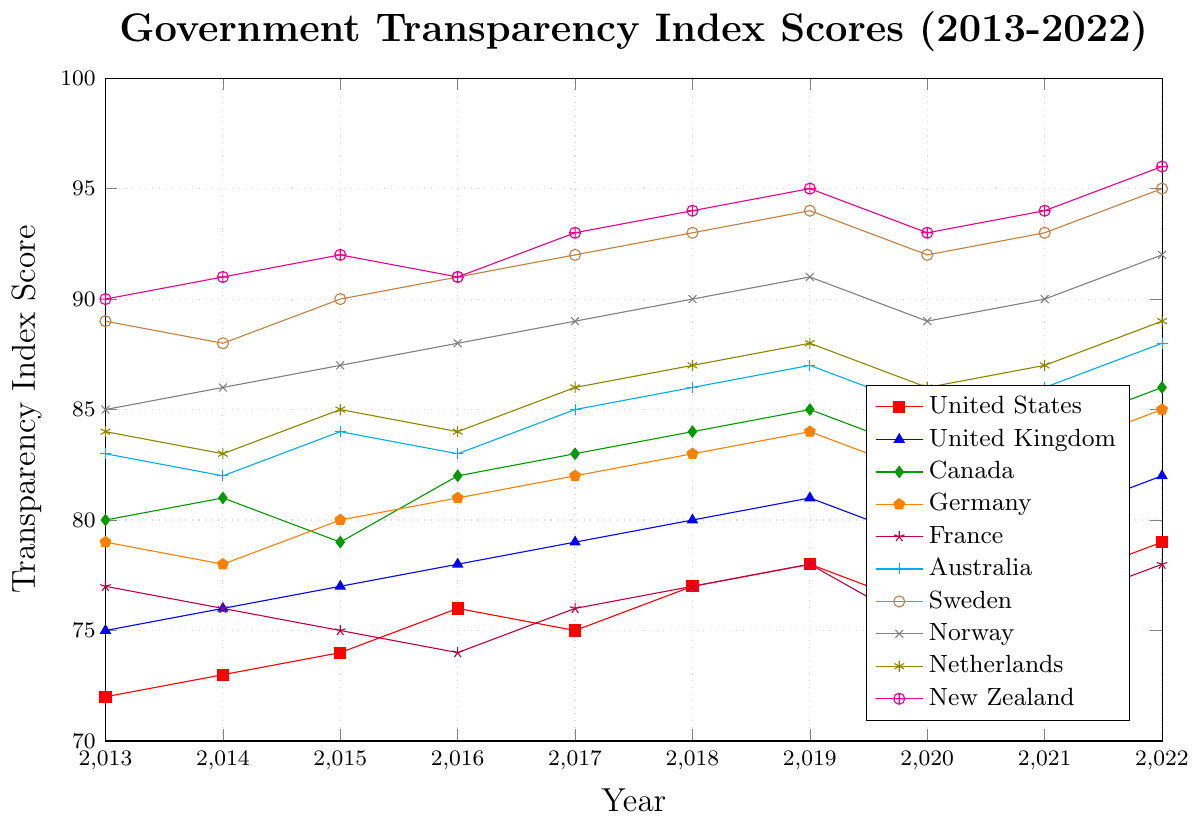What is the average transparency index score for the United States from 2013 to 2022? To calculate the average, sum up the transparency index scores for the years 2013 to 2022, then divide by the total number of years (10). Calculations: (72 + 73 + 74 + 76 + 75 + 77 + 78 + 76 + 77 + 79) / 10 = 757 / 10 = 75.7
Answer: 75.7 Which country had the highest transparency index score in 2018? To identify the country, look at the transparency index scores for 2018 and determine which is the highest. In 2018, New Zealand has the highest score of 94.
Answer: New Zealand In which year did Germany have the lowest transparency index score and what was it? Review the transparency index scores for Germany from 2013 to 2022 and find the minimum value and its corresponding year. The lowest score for Germany is 78 in 2014.
Answer: 2014, 78 By how many points did the transparency index score of France change from 2013 to 2022? To find the change, subtract France's transparency index score in 2013 from its score in 2022. Calculations: 78 - 77 = 1
Answer: 1 Among all the countries, which one showed the most consistent (least varied) transparency index score over the past decade? Consistency can be determined by looking for the smallest variation in scores over the years. Sweden shows the least variation with a steadily high score ranging from 89 to 95.
Answer: Sweden Compare the transparency index scores of the United Kingdom and Canada in 2022. Which country had a higher score and by how much? To compare, subtract the United Kingdom’s score from Canada’s score in 2022. Calculations: 86 - 82 = 4; therefore, Canada had a higher score by 4 points.
Answer: Canada, 4 Which country had the greatest increase in transparency index score from 2013 to 2022? To determine this, calculate the increase for each country from 2013 to 2022 and find the largest value. New Zealand had the greatest increase, from 90 to 96, a total of 6 points.
Answer: New Zealand What is the median transparency index score of the Netherlands over the period from 2013 to 2022? List the Netherlands' scores for each year, sort them, and find the middle value. Scores: 83, 84, 84, 85, 85, 86, 86, 87, 87, 89. The median is the average of the 5th and 6th values (85 and 86). Calculations: (85 + 86) / 2 = 85.5
Answer: 85.5 How many times did the transparency index score of Australia decline compared to the previous year between 2013 and 2022? Compare each year’s score with the previous year’s score. The declines occurred from 2013 to 2014 (83 to 82) and from 2016 to 2017 (83 to 85, no decline). Two declines are found.
Answer: 1 Which two countries had the same transparency index score in 2022 and what was the score? Compare the transparency index scores for 2022 for all countries to identify any matches. Australia and Germany both had scores of 85 in 2022.
Answer: Australia, Germany, 85 